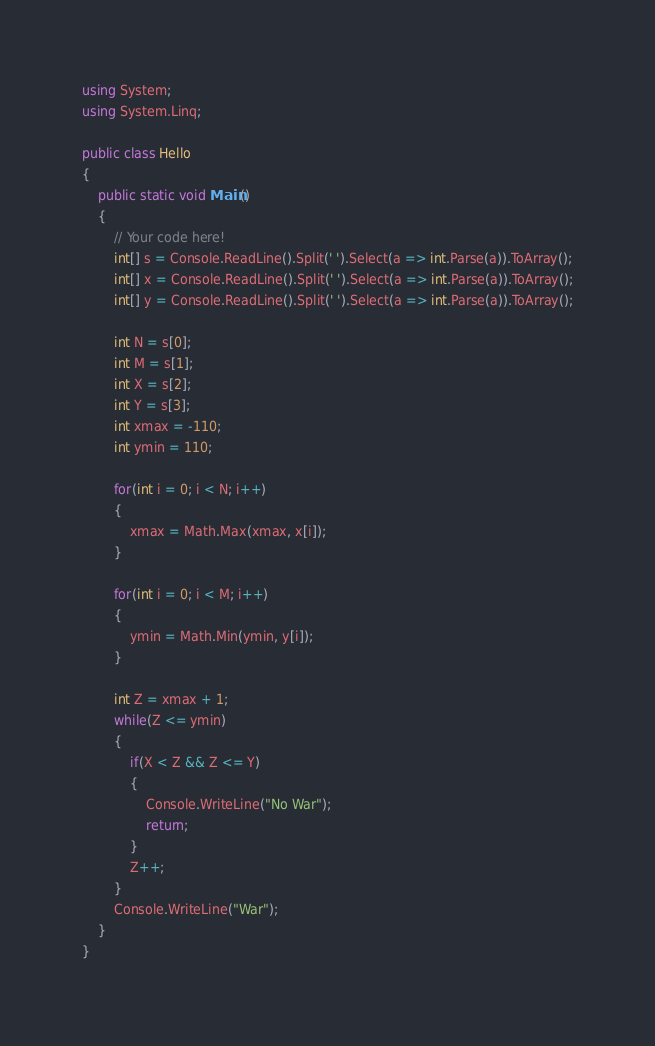Convert code to text. <code><loc_0><loc_0><loc_500><loc_500><_C#_>using System;
using System.Linq;

public class Hello
{
    public static void Main()
    {
        // Your code here!
        int[] s = Console.ReadLine().Split(' ').Select(a => int.Parse(a)).ToArray();
        int[] x = Console.ReadLine().Split(' ').Select(a => int.Parse(a)).ToArray();
        int[] y = Console.ReadLine().Split(' ').Select(a => int.Parse(a)).ToArray();
        
        int N = s[0];
        int M = s[1];
        int X = s[2];
        int Y = s[3];
        int xmax = -110;
        int ymin = 110;
        
        for(int i = 0; i < N; i++)
        {
            xmax = Math.Max(xmax, x[i]);
        }
        
        for(int i = 0; i < M; i++)
        {
            ymin = Math.Min(ymin, y[i]);
        }
        
        int Z = xmax + 1;
        while(Z <= ymin)
        {
            if(X < Z && Z <= Y)
            {
                Console.WriteLine("No War");
                return;
            }
            Z++;
        }
        Console.WriteLine("War");
    }
}</code> 